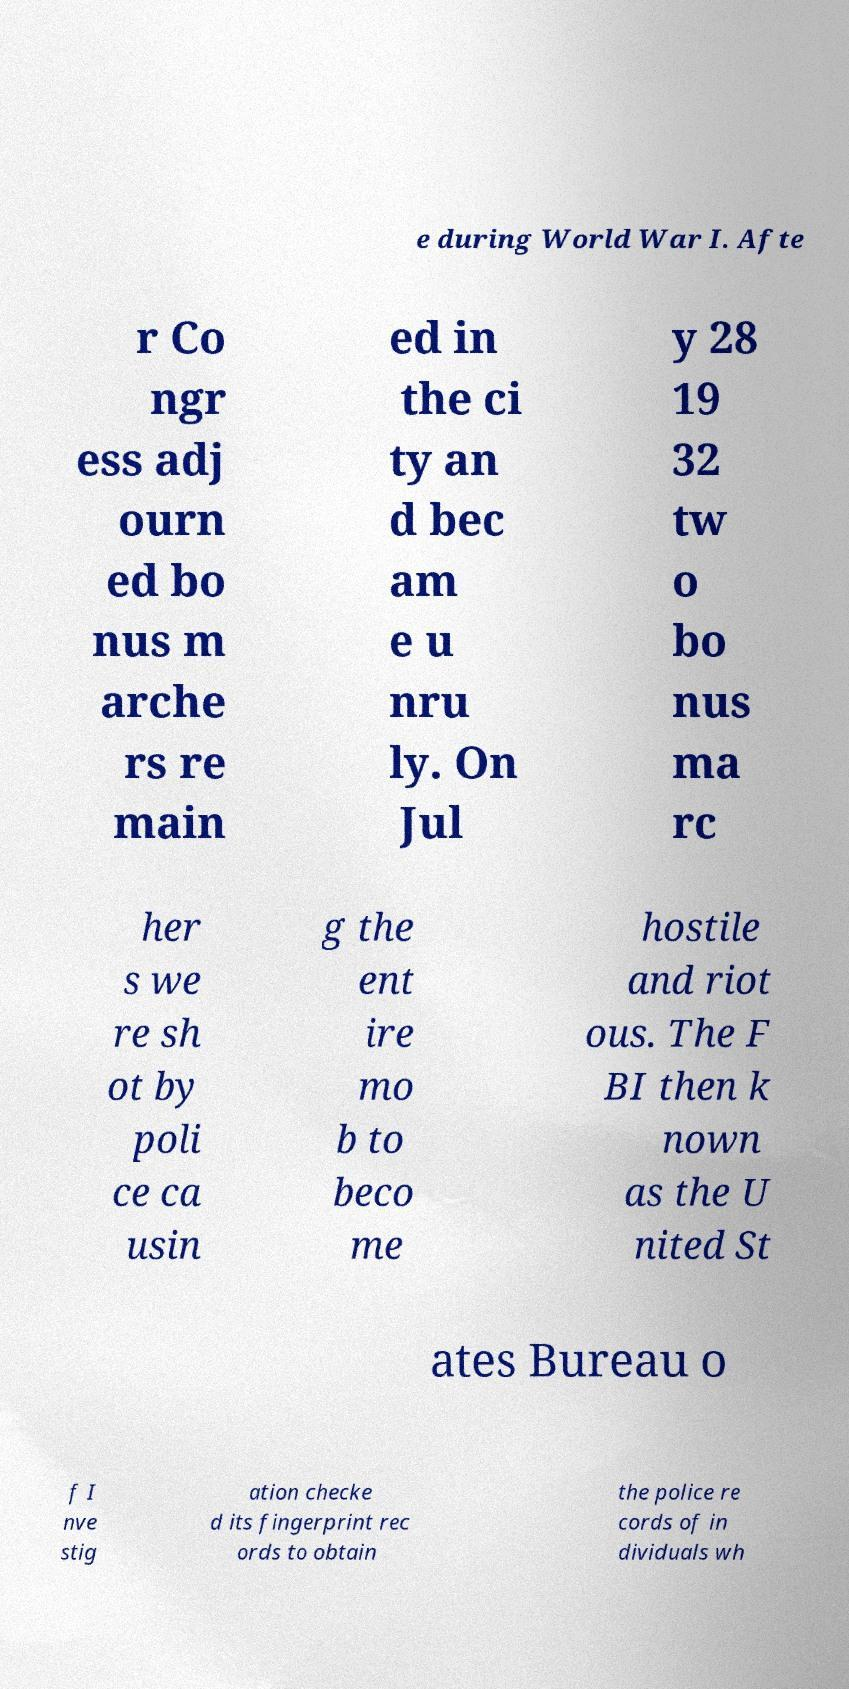What messages or text are displayed in this image? I need them in a readable, typed format. e during World War I. Afte r Co ngr ess adj ourn ed bo nus m arche rs re main ed in the ci ty an d bec am e u nru ly. On Jul y 28 19 32 tw o bo nus ma rc her s we re sh ot by poli ce ca usin g the ent ire mo b to beco me hostile and riot ous. The F BI then k nown as the U nited St ates Bureau o f I nve stig ation checke d its fingerprint rec ords to obtain the police re cords of in dividuals wh 